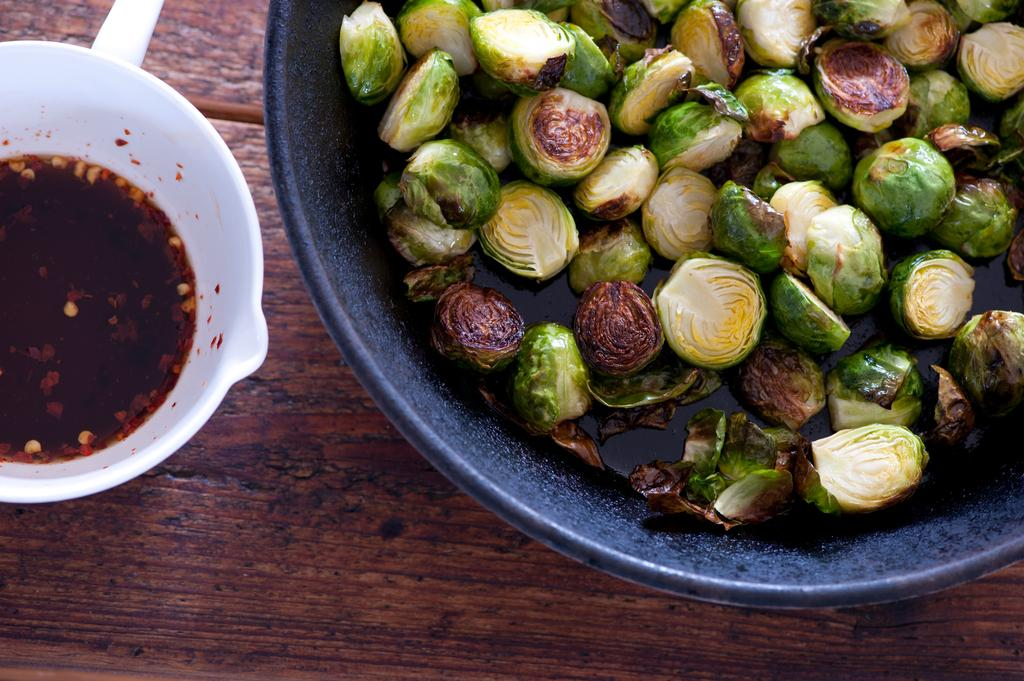What color is the bowl that contains Brussels sprouts? The bowl that contains Brussels sprouts is black. What is in the black bowl? The black bowl contains Brussels sprouts. What color is the other bowl in the image? The other bowl in the image is white. What is in the white bowl? The white bowl contains sauce. On what surface are the bowls placed? The bowls are placed on a brown table. How does the mask reduce friction between the Brussels sprouts and the black bowl? There is no mask present in the image, and the concept of friction is not applicable to the interaction between the Brussels sprouts and the black bowl. 